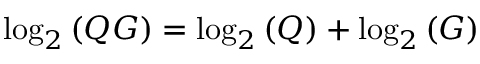<formula> <loc_0><loc_0><loc_500><loc_500>\log _ { 2 } { ( Q G ) } = \log _ { 2 } { ( Q ) } + \log _ { 2 } { ( G ) }</formula> 